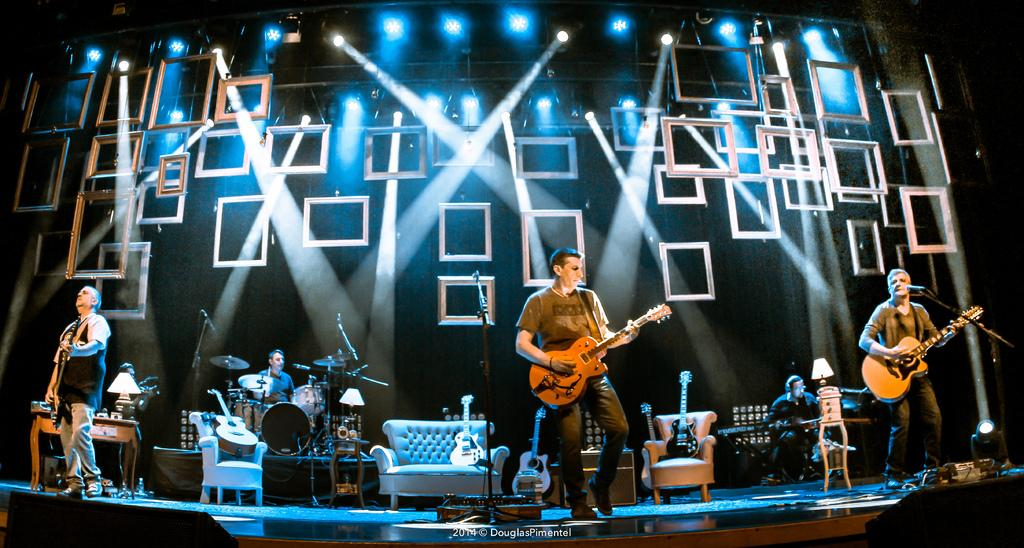What are the people in the image doing? The people in the image are playing musical instruments. What object is present for amplifying sound? There is a microphone in the image. What is the purpose of the stand in the image? The stand is likely used to hold sheet music or other items needed for the performance. What type of furniture can be seen in the background of the image? There is a couch, a table, and a lamp in the background of the image. How many dust particles can be seen floating around the cent in the image? There is no cent or dust particles visible in the image. What type of desk is present in the image? There is no desk present in the image. 